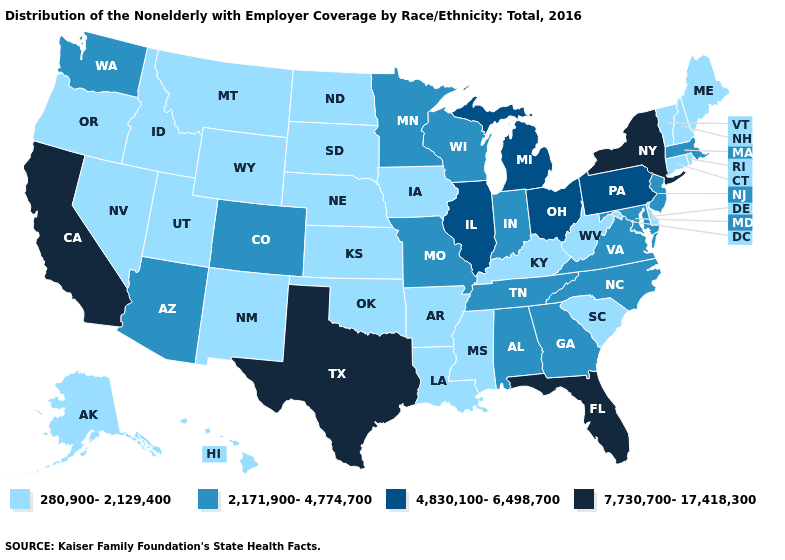Is the legend a continuous bar?
Concise answer only. No. Does Illinois have the same value as Arizona?
Quick response, please. No. Among the states that border Missouri , does Kansas have the highest value?
Be succinct. No. What is the lowest value in the USA?
Keep it brief. 280,900-2,129,400. Is the legend a continuous bar?
Give a very brief answer. No. What is the highest value in the USA?
Give a very brief answer. 7,730,700-17,418,300. Name the states that have a value in the range 2,171,900-4,774,700?
Short answer required. Alabama, Arizona, Colorado, Georgia, Indiana, Maryland, Massachusetts, Minnesota, Missouri, New Jersey, North Carolina, Tennessee, Virginia, Washington, Wisconsin. How many symbols are there in the legend?
Short answer required. 4. What is the value of South Dakota?
Answer briefly. 280,900-2,129,400. Does Georgia have the lowest value in the USA?
Short answer required. No. Does Maryland have a higher value than Florida?
Give a very brief answer. No. Name the states that have a value in the range 4,830,100-6,498,700?
Quick response, please. Illinois, Michigan, Ohio, Pennsylvania. Name the states that have a value in the range 280,900-2,129,400?
Answer briefly. Alaska, Arkansas, Connecticut, Delaware, Hawaii, Idaho, Iowa, Kansas, Kentucky, Louisiana, Maine, Mississippi, Montana, Nebraska, Nevada, New Hampshire, New Mexico, North Dakota, Oklahoma, Oregon, Rhode Island, South Carolina, South Dakota, Utah, Vermont, West Virginia, Wyoming. Which states have the highest value in the USA?
Keep it brief. California, Florida, New York, Texas. What is the lowest value in states that border Missouri?
Concise answer only. 280,900-2,129,400. 